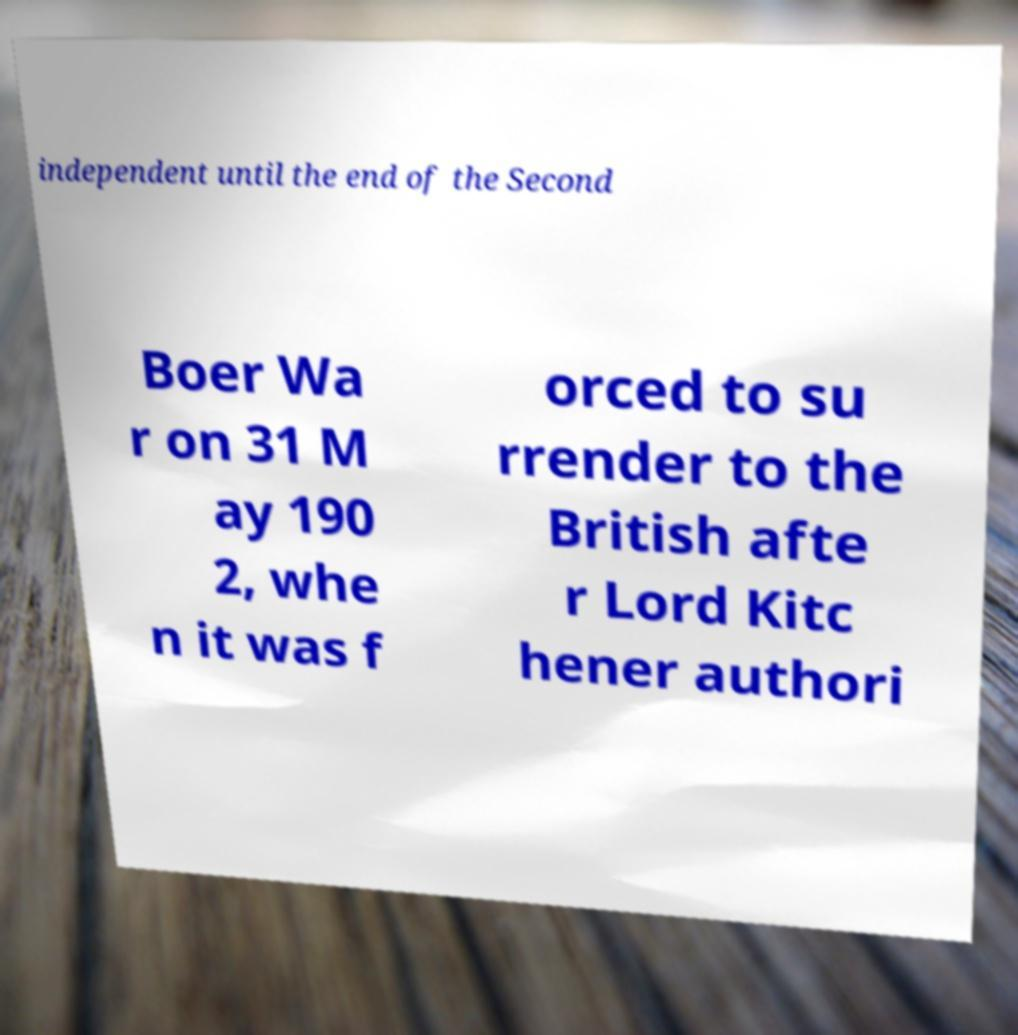Could you assist in decoding the text presented in this image and type it out clearly? independent until the end of the Second Boer Wa r on 31 M ay 190 2, whe n it was f orced to su rrender to the British afte r Lord Kitc hener authori 